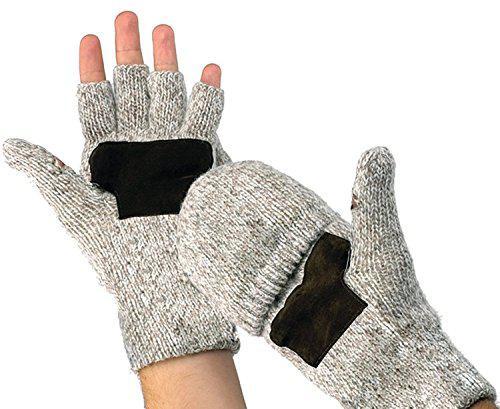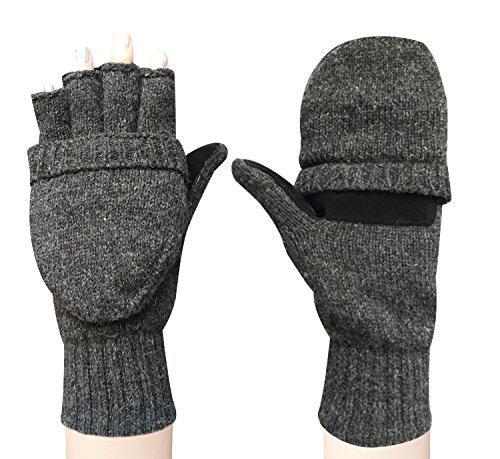The first image is the image on the left, the second image is the image on the right. Assess this claim about the two images: "Each image shows a complete pair of mittens.". Correct or not? Answer yes or no. Yes. The first image is the image on the left, the second image is the image on the right. Analyze the images presented: Is the assertion "An image shows one fingerless glove over black """"fingers""""." valid? Answer yes or no. No. 